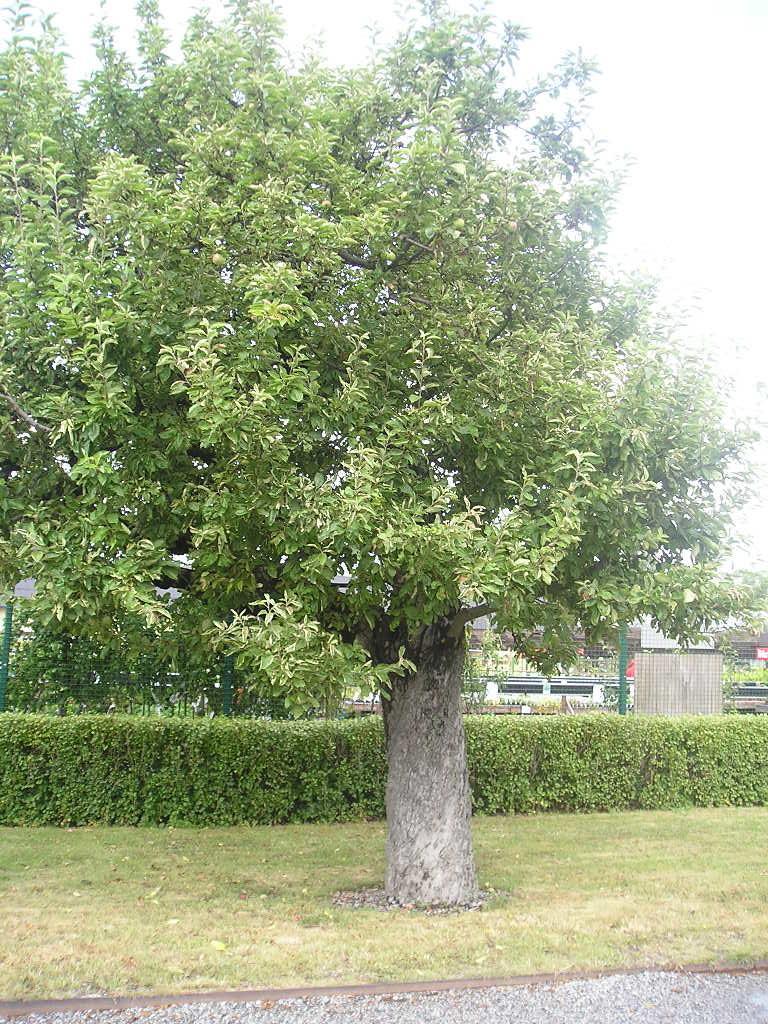Please provide a concise description of this image. In this picture I can observe a tree in the middle of the picture. In the background there are some plants on the ground. I can observe sky in the background. 